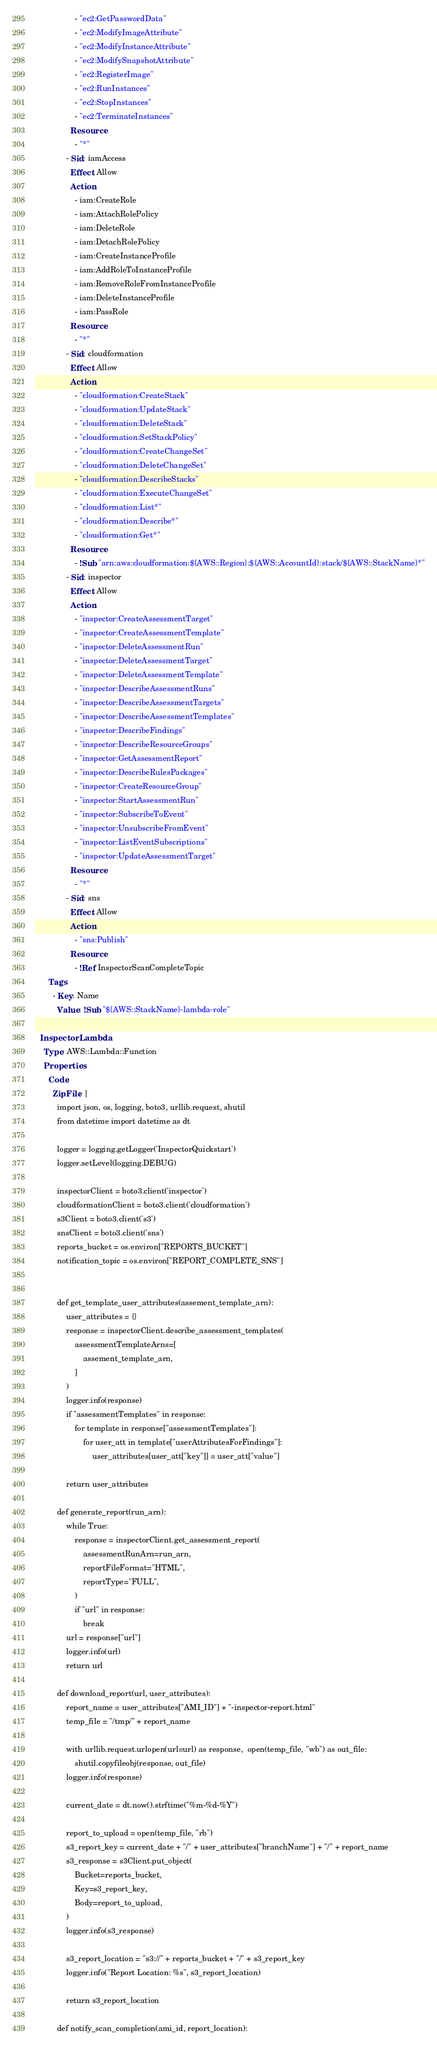Convert code to text. <code><loc_0><loc_0><loc_500><loc_500><_YAML_>                  - "ec2:GetPasswordData"
                  - "ec2:ModifyImageAttribute"
                  - "ec2:ModifyInstanceAttribute"
                  - "ec2:ModifySnapshotAttribute"
                  - "ec2:RegisterImage"
                  - "ec2:RunInstances"
                  - "ec2:StopInstances"
                  - "ec2:TerminateInstances"
                Resource:
                  - "*"
              - Sid: iamAccess
                Effect: Allow
                Action:
                  - iam:CreateRole
                  - iam:AttachRolePolicy
                  - iam:DeleteRole
                  - iam:DetachRolePolicy
                  - iam:CreateInstanceProfile
                  - iam:AddRoleToInstanceProfile
                  - iam:RemoveRoleFromInstanceProfile
                  - iam:DeleteInstanceProfile
                  - iam:PassRole
                Resource:
                  - "*"                  
              - Sid: cloudformation
                Effect: Allow
                Action:
                  - "cloudformation:CreateStack"
                  - "cloudformation:UpdateStack"
                  - "cloudformation:DeleteStack"
                  - "cloudformation:SetStackPolicy"
                  - "cloudformation:CreateChangeSet"
                  - "cloudformation:DeleteChangeSet"
                  - "cloudformation:DescribeStacks"
                  - "cloudformation:ExecuteChangeSet"
                  - "cloudformation:List*"
                  - "cloudformation:Describe*"
                  - "cloudformation:Get*"
                Resource:
                  - !Sub "arn:aws:cloudformation:${AWS::Region}:${AWS::AccountId}:stack/${AWS::StackName}*"
              - Sid: inspector
                Effect: Allow
                Action:
                  - "inspector:CreateAssessmentTarget"
                  - "inspector:CreateAssessmentTemplate"
                  - "inspector:DeleteAssessmentRun"
                  - "inspector:DeleteAssessmentTarget"
                  - "inspector:DeleteAssessmentTemplate"
                  - "inspector:DescribeAssessmentRuns"
                  - "inspector:DescribeAssessmentTargets"
                  - "inspector:DescribeAssessmentTemplates"
                  - "inspector:DescribeFindings"
                  - "inspector:DescribeResourceGroups"
                  - "inspector:GetAssessmentReport"
                  - "inspector:DescribeRulesPackages"
                  - "inspector:CreateResourceGroup"
                  - "inspector:StartAssessmentRun"
                  - "inspector:SubscribeToEvent"
                  - "inspector:UnsubscribeFromEvent"
                  - "inspector:ListEventSubscriptions"
                  - "inspector:UpdateAssessmentTarget"
                Resource:
                  - "*"
              - Sid: sns
                Effect: Allow
                Action:
                  - "sns:Publish"
                Resource:
                  - !Ref InspectorScanCompleteTopic
      Tags:
        - Key: Name
          Value: !Sub "${AWS::StackName}-lambda-role"
  
  InspectorLambda:
    Type: AWS::Lambda::Function
    Properties: 
      Code: 
        ZipFile: |
          import json, os, logging, boto3, urllib.request, shutil
          from datetime import datetime as dt

          logger = logging.getLogger('InspectorQuickstart')
          logger.setLevel(logging.DEBUG)

          inspectorClient = boto3.client('inspector')
          cloudformationClient = boto3.client('cloudformation')
          s3Client = boto3.client('s3')
          snsClient = boto3.client('sns')
          reports_bucket = os.environ["REPORTS_BUCKET"]
          notification_topic = os.environ["REPORT_COMPLETE_SNS"]


          def get_template_user_attributes(assement_template_arn):
              user_attributes = {}
              response = inspectorClient.describe_assessment_templates(
                  assessmentTemplateArns=[
                      assement_template_arn,
                  ]
              )
              logger.info(response)
              if "assessmentTemplates" in response:
                  for template in response["assessmentTemplates"]:
                      for user_att in template["userAttributesForFindings"]:
                          user_attributes[user_att["key"]] = user_att["value"]

              return user_attributes

          def generate_report(run_arn):
              while True:
                  response = inspectorClient.get_assessment_report(
                      assessmentRunArn=run_arn,
                      reportFileFormat="HTML",
                      reportType="FULL",
                  )
                  if "url" in response:
                      break
              url = response["url"]
              logger.info(url)
              return url

          def download_report(url, user_attributes):
              report_name = user_attributes["AMI_ID"] + "-inspector-report.html"
              temp_file = "/tmp/" + report_name
              
              with urllib.request.urlopen(url=url) as response,  open(temp_file, "wb") as out_file:
                  shutil.copyfileobj(response, out_file)
              logger.info(response)

              current_date = dt.now().strftime("%m-%d-%Y")

              report_to_upload = open(temp_file, "rb")
              s3_report_key = current_date + "/" + user_attributes["branchName"] + "/" + report_name
              s3_response = s3Client.put_object(
                  Bucket=reports_bucket,
                  Key=s3_report_key,
                  Body=report_to_upload,
              )
              logger.info(s3_response)

              s3_report_location = "s3://" + reports_bucket + "/" + s3_report_key
              logger.info("Report Location: %s", s3_report_location)

              return s3_report_location

          def notify_scan_completion(ami_id, report_location):</code> 